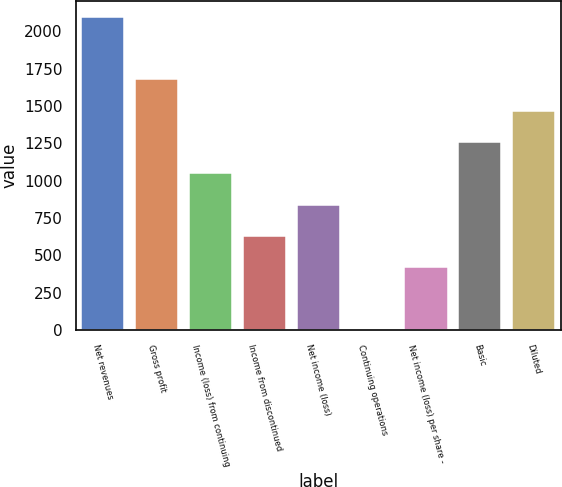Convert chart. <chart><loc_0><loc_0><loc_500><loc_500><bar_chart><fcel>Net revenues<fcel>Gross profit<fcel>Income (loss) from continuing<fcel>Income from discontinued<fcel>Net income (loss)<fcel>Continuing operations<fcel>Net income (loss) per share -<fcel>Basic<fcel>Diluted<nl><fcel>2099<fcel>1679.31<fcel>1049.74<fcel>630.03<fcel>839.88<fcel>0.45<fcel>420.17<fcel>1259.6<fcel>1469.45<nl></chart> 